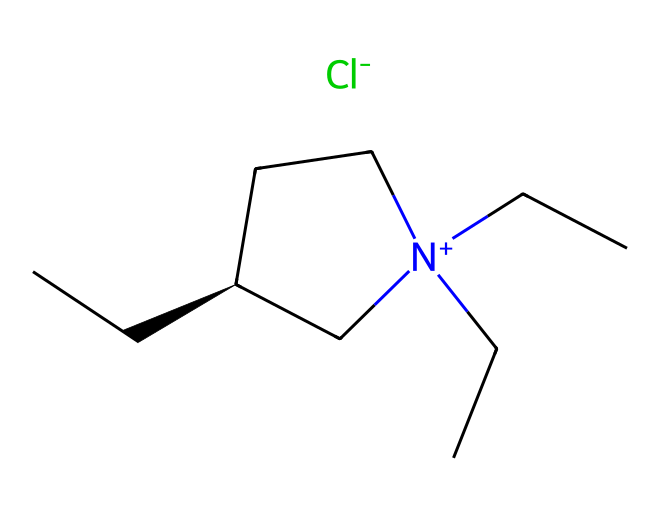what is the central atom in this compound? The structure contains a chiral carbon atom denoted by [C@H], which indicates it is a stereocenter in the molecule. This carbon atom serves as the central atom that connects to multiple substituents.
Answer: chiral carbon how many carbon atoms are in this compound? By analyzing the SMILES representation, there are four distinct carbon atoms from the hydrocarbon chains connected to the nitrogen atom, in addition to the chiral carbon. Counting all carbon atoms leads to a total of eight.
Answer: eight what type of ions are present in this ionic liquid? The chemical structure shows a positively charged nitrogen atom represented as [N+], and a negatively charged chlorine atom, indicated as [Cl-], which together define this compound as an ionic liquid.
Answer: cation and anion what is the role of the alkyl groups in this ionic liquid? The alkyl groups (in this case, the butyl chains attached to the nitrogen) introduce hydrophobic characteristics and influence the viscosity and thermal stability of the ionic liquid, making it suitable for document preservation applications.
Answer: hydrophobic characteristics how does the ionic nature of this liquid impact its application in preservation? The ionic nature of this liquid allows it to have a low vapor pressure and high thermal stability, preventing degradation of sensitive materials like historical documents while providing solubility properties that can assist in conservation.
Answer: low vapor pressure what does the presence of a chloride ion imply for the properties of this ionic liquid? The chloride ion contributes to the overall charge balance and stability of the ionic liquid, affecting its interaction with substrates and influencing its solvation properties, enhancing its effectiveness for preservation methods.
Answer: charge balance 